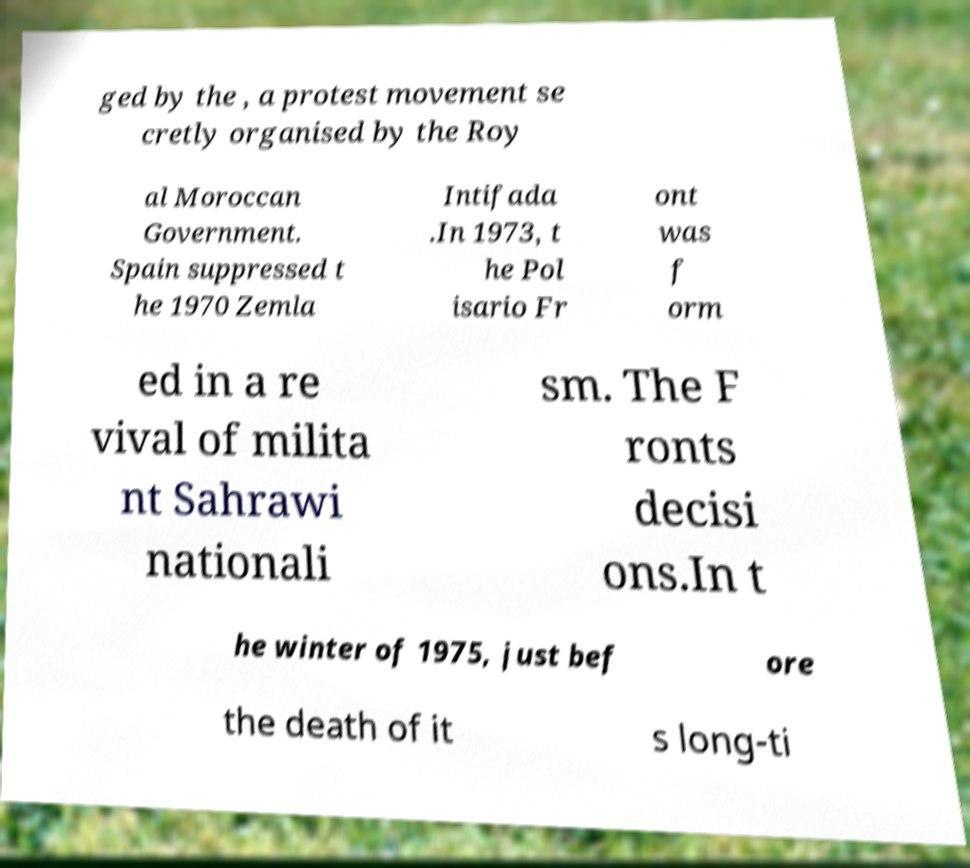I need the written content from this picture converted into text. Can you do that? ged by the , a protest movement se cretly organised by the Roy al Moroccan Government. Spain suppressed t he 1970 Zemla Intifada .In 1973, t he Pol isario Fr ont was f orm ed in a re vival of milita nt Sahrawi nationali sm. The F ronts decisi ons.In t he winter of 1975, just bef ore the death of it s long-ti 